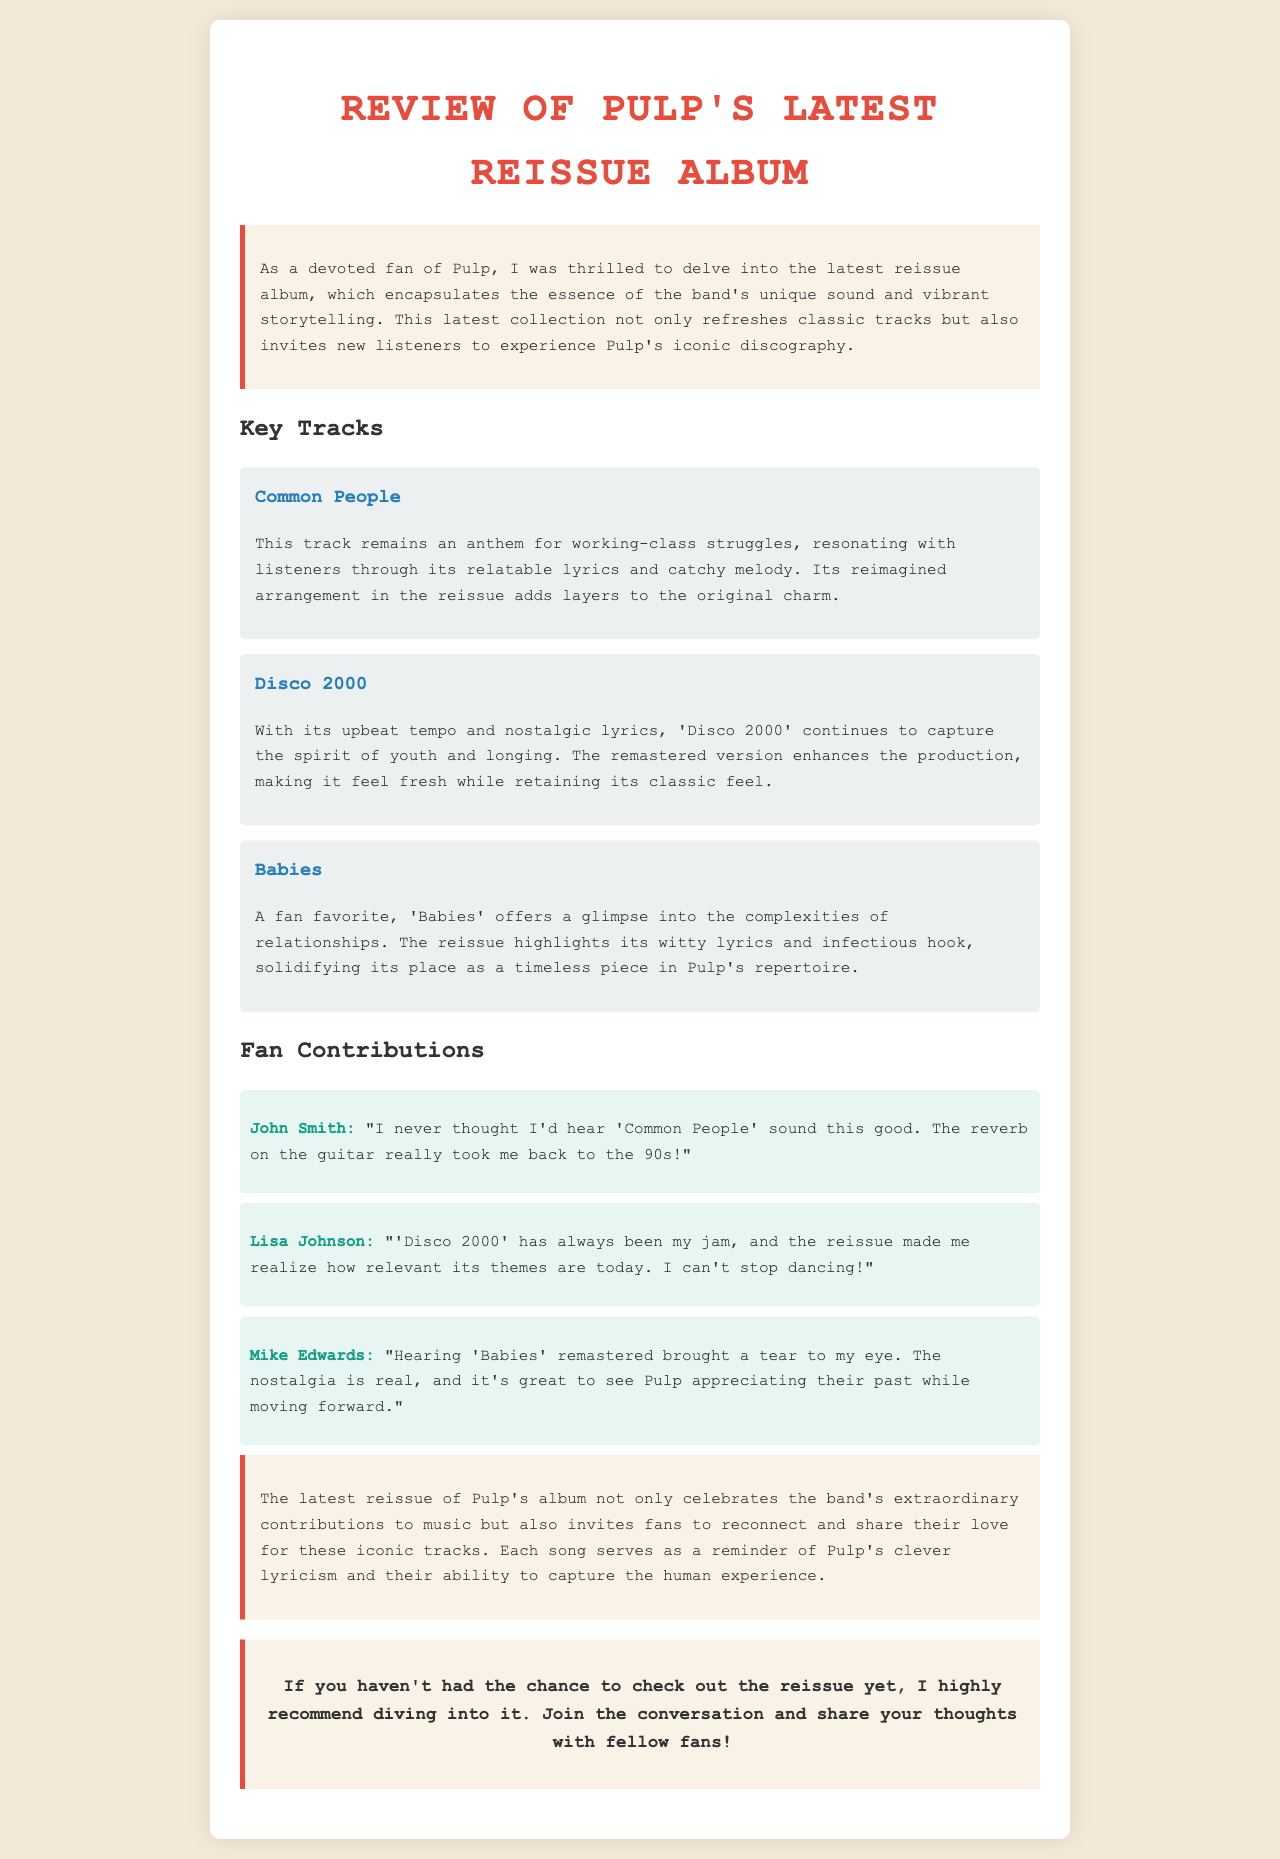What is the title of the document? The title is displayed prominently at the top of the document.
Answer: Review of Pulp's Latest Reissue Album How many key tracks are highlighted in the review? The document lists three specific key tracks that are emphasized in the review.
Answer: Three What is a key theme of the track "Common People"? The review mentions that this track resonates with listeners through its relatable lyrics and catchy melody, particularly focusing on working-class struggles.
Answer: Working-class struggles Which track is described as a fan favorite? The document specifically names "Babies" as a fan favorite among the band's repertoire.
Answer: Babies Who commented on how good 'Common People' sounds in the reissue? The document includes a fan comment from John Smith regarding the quality of the track in the reissue.
Answer: John Smith What does Lisa Johnson express about 'Disco 2000'? The fan comment reflects her feelings about the relevance of 'Disco 2000's themes today and her enjoyment of the reissue.
Answer: Relevance of themes What emotion did Mike Edwards express about hearing 'Babies' remastered? The document notes that Mike Edwards expressed nostalgia upon hearing the remastered version of the track.
Answer: Nostalgia What invitation does the document extend to fans at the end? The conclusion encourages readers to join the conversation and share their thoughts with fellow fans regarding the reissue.
Answer: Join the conversation 